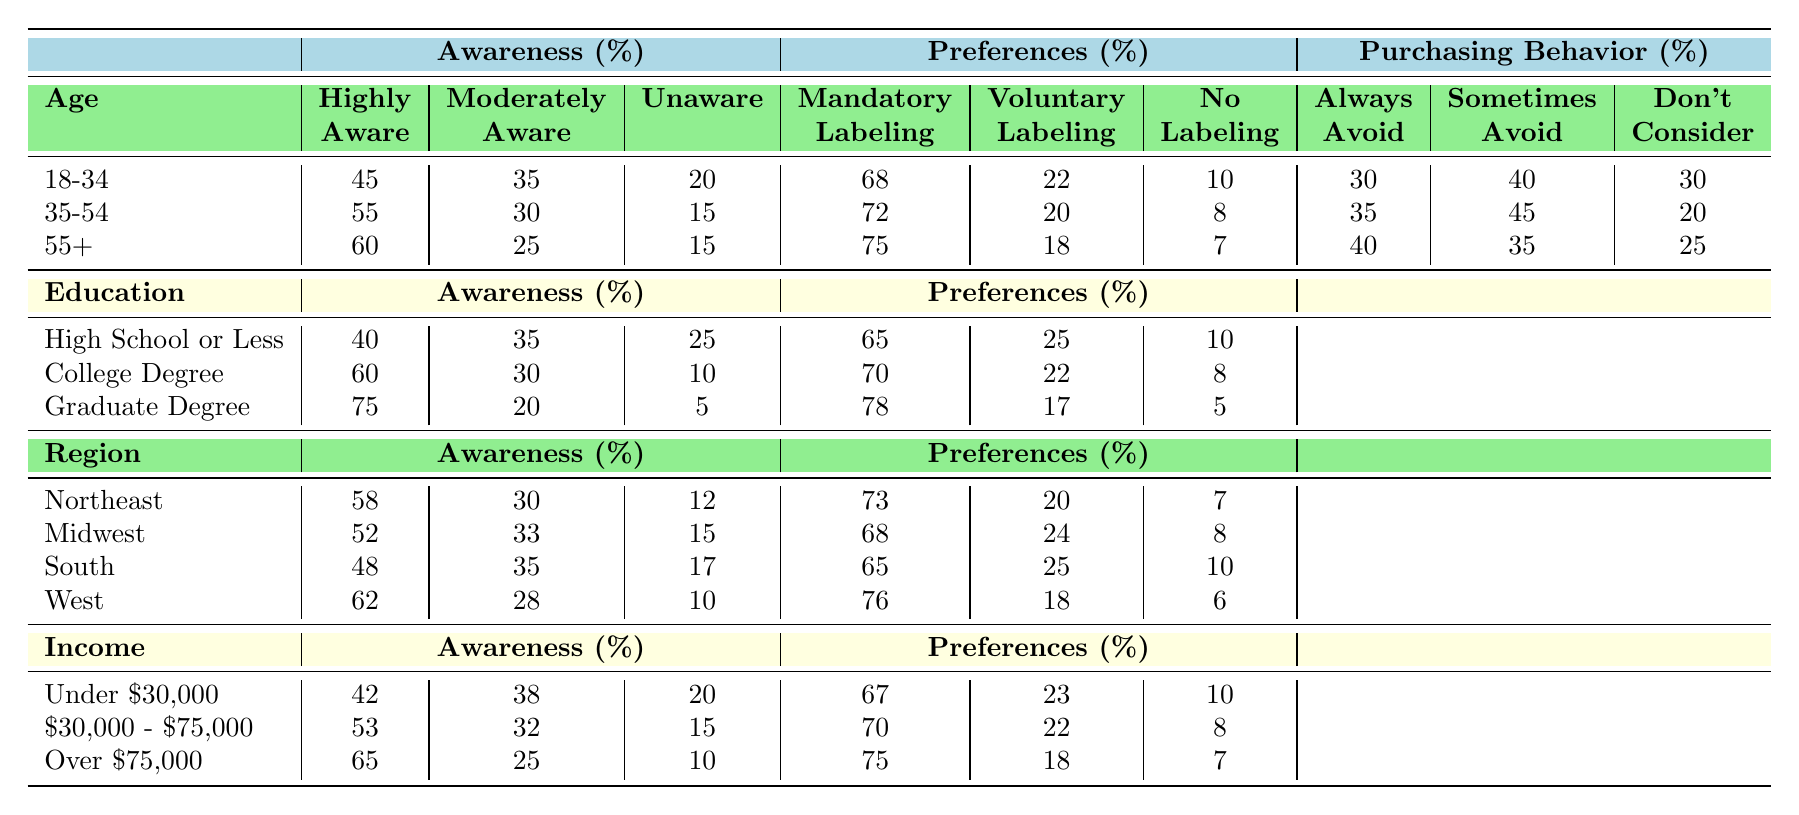What percentage of the 18-34 age group is highly aware of GMO labeling? Referring to the table, the "Highly Aware" percentage for the 18-34 age group is listed as 45%.
Answer: 45% What is the preference for mandatory labeling among individuals with a graduate degree? The table shows that individuals with a graduate degree prefer mandatory labeling at a rate of 78%.
Answer: 78% In which educational group is the percentage of highly aware individuals the highest? Comparing the "Highly Aware" percentages across the educational groups: High School or Less (40%), College Degree (60%), Graduate Degree (75%), the highest is 75% for those with a Graduate Degree.
Answer: Graduate Degree What is the difference in preference for mandatory labeling between the 35-54 age group and the 55+ age group? The 35-54 age group has a preference of 72% for mandatory labeling, while the 55+ age group has 75%. The difference is 75 - 72 = 3%.
Answer: 3% Is it true that the South has a higher percentage of individuals who always avoid GMOs compared to the Midwest? The Southern region shows that 48% always avoid GMOs, whereas in the Midwest it is 35%. Therefore, it is true that the South has a higher percentage.
Answer: Yes What average percentage of awareness (highly, moderately, and unaware) do individuals with a college degree exhibit? For the College Degree group, the percentages for awareness are Highly Aware (60%), Moderately Aware (30%), and Unaware (10%). The average is (60 + 30 + 10) / 3 = 33.33%.
Answer: 33.33% Which demographic group shows the lowest percentage of awareness of GMOs? Looking across all groups, the group with the lowest percentage of "Highly Aware" status is the "Under $30,000" income group, which has 42% as the lowest awareness overall compared to other demographic categories.
Answer: Under $30,000 How many percent of the 55+ age group prefer no labeling? In the table, the 55+ age group's preference for no labeling is recorded as 7%.
Answer: 7% Among income levels, which group exhibits the highest percentage of individuals who are moderately aware of GMOs? The table shows that the income level group "$30,000 - $75,000" has 32% of individuals who are moderately aware, which is higher than the other income groups (Under $30,000 at 38% and Over $75,000 at 25%). Hence, the highest percentage of individuals moderately aware is 38% found in the Under $30,000 income category.
Answer: Under $30,000 What percentage of the Northeast region prefers no labeling? The Northeast region has a preference for no labeling recorded at 7%.
Answer: 7% Which age group has the highest percentage of individuals who sometimes avoid GMOs? The 35-54 age group shows a percentage of 45% for sometimes avoiding GMOs, which is higher than 40% for the 18-34 age group and 35% for the 55+ age group.
Answer: 35-54 age group 